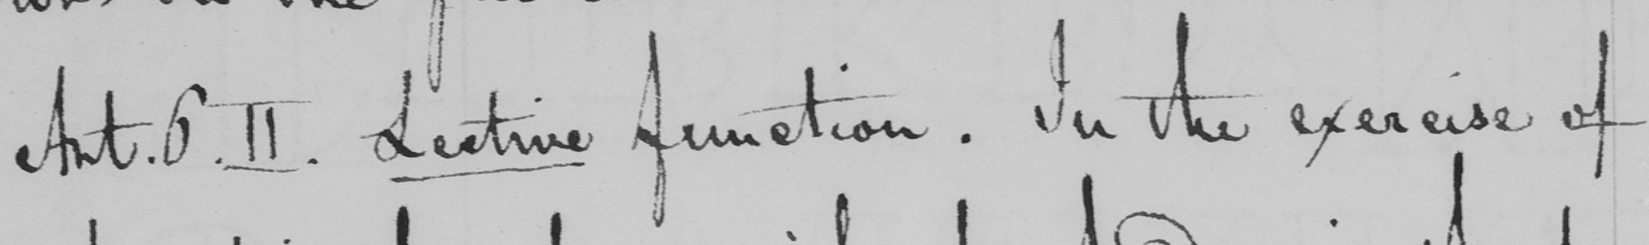Can you read and transcribe this handwriting? Art.6.II . Lecture function . In the exercise of 